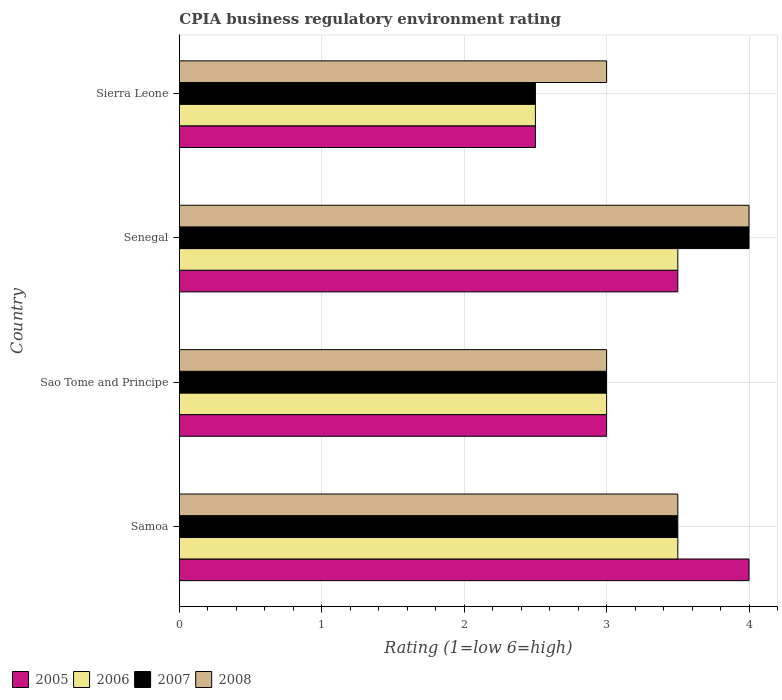How many bars are there on the 1st tick from the top?
Offer a terse response. 4. How many bars are there on the 1st tick from the bottom?
Offer a terse response. 4. What is the label of the 1st group of bars from the top?
Provide a short and direct response. Sierra Leone. What is the CPIA rating in 2007 in Senegal?
Give a very brief answer. 4. Across all countries, what is the minimum CPIA rating in 2007?
Provide a short and direct response. 2.5. In which country was the CPIA rating in 2008 maximum?
Provide a short and direct response. Senegal. In which country was the CPIA rating in 2006 minimum?
Your response must be concise. Sierra Leone. What is the total CPIA rating in 2005 in the graph?
Make the answer very short. 13. What is the difference between the CPIA rating in 2005 in Sao Tome and Principe and that in Sierra Leone?
Your answer should be compact. 0.5. What is the average CPIA rating in 2005 per country?
Make the answer very short. 3.25. What is the difference between the CPIA rating in 2007 and CPIA rating in 2006 in Samoa?
Offer a very short reply. 0. What is the ratio of the CPIA rating in 2005 in Senegal to that in Sierra Leone?
Your answer should be very brief. 1.4. What is the difference between the highest and the second highest CPIA rating in 2008?
Provide a succinct answer. 0.5. Is the sum of the CPIA rating in 2007 in Samoa and Senegal greater than the maximum CPIA rating in 2005 across all countries?
Your response must be concise. Yes. Is it the case that in every country, the sum of the CPIA rating in 2008 and CPIA rating in 2005 is greater than the sum of CPIA rating in 2006 and CPIA rating in 2007?
Your response must be concise. No. How many bars are there?
Give a very brief answer. 16. What is the difference between two consecutive major ticks on the X-axis?
Give a very brief answer. 1. Are the values on the major ticks of X-axis written in scientific E-notation?
Make the answer very short. No. What is the title of the graph?
Make the answer very short. CPIA business regulatory environment rating. What is the label or title of the Y-axis?
Your response must be concise. Country. What is the Rating (1=low 6=high) of 2005 in Sao Tome and Principe?
Offer a very short reply. 3. What is the Rating (1=low 6=high) of 2007 in Senegal?
Offer a terse response. 4. What is the Rating (1=low 6=high) in 2008 in Senegal?
Offer a terse response. 4. What is the Rating (1=low 6=high) in 2005 in Sierra Leone?
Provide a short and direct response. 2.5. What is the Rating (1=low 6=high) of 2006 in Sierra Leone?
Make the answer very short. 2.5. Across all countries, what is the maximum Rating (1=low 6=high) in 2006?
Keep it short and to the point. 3.5. Across all countries, what is the maximum Rating (1=low 6=high) in 2007?
Your response must be concise. 4. Across all countries, what is the maximum Rating (1=low 6=high) in 2008?
Provide a succinct answer. 4. Across all countries, what is the minimum Rating (1=low 6=high) in 2006?
Keep it short and to the point. 2.5. Across all countries, what is the minimum Rating (1=low 6=high) of 2007?
Ensure brevity in your answer.  2.5. What is the total Rating (1=low 6=high) in 2005 in the graph?
Give a very brief answer. 13. What is the total Rating (1=low 6=high) in 2006 in the graph?
Provide a short and direct response. 12.5. What is the difference between the Rating (1=low 6=high) of 2005 in Samoa and that in Sao Tome and Principe?
Make the answer very short. 1. What is the difference between the Rating (1=low 6=high) of 2006 in Samoa and that in Sao Tome and Principe?
Offer a terse response. 0.5. What is the difference between the Rating (1=low 6=high) of 2008 in Samoa and that in Senegal?
Your answer should be compact. -0.5. What is the difference between the Rating (1=low 6=high) of 2005 in Samoa and that in Sierra Leone?
Your answer should be very brief. 1.5. What is the difference between the Rating (1=low 6=high) in 2006 in Samoa and that in Sierra Leone?
Make the answer very short. 1. What is the difference between the Rating (1=low 6=high) of 2005 in Sao Tome and Principe and that in Sierra Leone?
Offer a terse response. 0.5. What is the difference between the Rating (1=low 6=high) of 2007 in Sao Tome and Principe and that in Sierra Leone?
Give a very brief answer. 0.5. What is the difference between the Rating (1=low 6=high) in 2006 in Senegal and that in Sierra Leone?
Keep it short and to the point. 1. What is the difference between the Rating (1=low 6=high) of 2007 in Senegal and that in Sierra Leone?
Keep it short and to the point. 1.5. What is the difference between the Rating (1=low 6=high) of 2008 in Senegal and that in Sierra Leone?
Your answer should be compact. 1. What is the difference between the Rating (1=low 6=high) of 2005 in Samoa and the Rating (1=low 6=high) of 2006 in Sao Tome and Principe?
Your answer should be compact. 1. What is the difference between the Rating (1=low 6=high) of 2006 in Samoa and the Rating (1=low 6=high) of 2007 in Sao Tome and Principe?
Keep it short and to the point. 0.5. What is the difference between the Rating (1=low 6=high) in 2006 in Samoa and the Rating (1=low 6=high) in 2008 in Sao Tome and Principe?
Provide a succinct answer. 0.5. What is the difference between the Rating (1=low 6=high) in 2005 in Samoa and the Rating (1=low 6=high) in 2007 in Senegal?
Your answer should be compact. 0. What is the difference between the Rating (1=low 6=high) in 2007 in Samoa and the Rating (1=low 6=high) in 2008 in Senegal?
Provide a short and direct response. -0.5. What is the difference between the Rating (1=low 6=high) in 2005 in Samoa and the Rating (1=low 6=high) in 2006 in Sierra Leone?
Your answer should be compact. 1.5. What is the difference between the Rating (1=low 6=high) in 2005 in Samoa and the Rating (1=low 6=high) in 2008 in Sierra Leone?
Your answer should be very brief. 1. What is the difference between the Rating (1=low 6=high) of 2006 in Samoa and the Rating (1=low 6=high) of 2008 in Sierra Leone?
Offer a terse response. 0.5. What is the difference between the Rating (1=low 6=high) of 2005 in Sao Tome and Principe and the Rating (1=low 6=high) of 2006 in Senegal?
Keep it short and to the point. -0.5. What is the difference between the Rating (1=low 6=high) of 2005 in Sao Tome and Principe and the Rating (1=low 6=high) of 2007 in Senegal?
Your response must be concise. -1. What is the difference between the Rating (1=low 6=high) in 2005 in Sao Tome and Principe and the Rating (1=low 6=high) in 2008 in Senegal?
Provide a short and direct response. -1. What is the difference between the Rating (1=low 6=high) in 2006 in Sao Tome and Principe and the Rating (1=low 6=high) in 2007 in Senegal?
Keep it short and to the point. -1. What is the difference between the Rating (1=low 6=high) in 2007 in Sao Tome and Principe and the Rating (1=low 6=high) in 2008 in Senegal?
Offer a very short reply. -1. What is the difference between the Rating (1=low 6=high) of 2005 in Sao Tome and Principe and the Rating (1=low 6=high) of 2008 in Sierra Leone?
Make the answer very short. 0. What is the difference between the Rating (1=low 6=high) of 2006 in Sao Tome and Principe and the Rating (1=low 6=high) of 2007 in Sierra Leone?
Give a very brief answer. 0.5. What is the difference between the Rating (1=low 6=high) in 2006 in Sao Tome and Principe and the Rating (1=low 6=high) in 2008 in Sierra Leone?
Offer a terse response. 0. What is the difference between the Rating (1=low 6=high) in 2005 in Senegal and the Rating (1=low 6=high) in 2006 in Sierra Leone?
Keep it short and to the point. 1. What is the difference between the Rating (1=low 6=high) of 2005 in Senegal and the Rating (1=low 6=high) of 2008 in Sierra Leone?
Give a very brief answer. 0.5. What is the average Rating (1=low 6=high) in 2005 per country?
Offer a very short reply. 3.25. What is the average Rating (1=low 6=high) in 2006 per country?
Make the answer very short. 3.12. What is the average Rating (1=low 6=high) in 2007 per country?
Offer a terse response. 3.25. What is the average Rating (1=low 6=high) in 2008 per country?
Provide a succinct answer. 3.38. What is the difference between the Rating (1=low 6=high) of 2005 and Rating (1=low 6=high) of 2008 in Samoa?
Ensure brevity in your answer.  0.5. What is the difference between the Rating (1=low 6=high) of 2006 and Rating (1=low 6=high) of 2007 in Samoa?
Your answer should be very brief. 0. What is the difference between the Rating (1=low 6=high) of 2006 and Rating (1=low 6=high) of 2008 in Samoa?
Keep it short and to the point. 0. What is the difference between the Rating (1=low 6=high) of 2005 and Rating (1=low 6=high) of 2008 in Sao Tome and Principe?
Give a very brief answer. 0. What is the difference between the Rating (1=low 6=high) in 2006 and Rating (1=low 6=high) in 2008 in Sao Tome and Principe?
Ensure brevity in your answer.  0. What is the difference between the Rating (1=low 6=high) of 2007 and Rating (1=low 6=high) of 2008 in Sao Tome and Principe?
Your answer should be very brief. 0. What is the difference between the Rating (1=low 6=high) of 2005 and Rating (1=low 6=high) of 2008 in Senegal?
Offer a very short reply. -0.5. What is the difference between the Rating (1=low 6=high) in 2007 and Rating (1=low 6=high) in 2008 in Senegal?
Your response must be concise. 0. What is the difference between the Rating (1=low 6=high) in 2005 and Rating (1=low 6=high) in 2006 in Sierra Leone?
Your answer should be very brief. 0. What is the difference between the Rating (1=low 6=high) in 2005 and Rating (1=low 6=high) in 2008 in Sierra Leone?
Give a very brief answer. -0.5. What is the difference between the Rating (1=low 6=high) in 2006 and Rating (1=low 6=high) in 2007 in Sierra Leone?
Make the answer very short. 0. What is the difference between the Rating (1=low 6=high) of 2006 and Rating (1=low 6=high) of 2008 in Sierra Leone?
Ensure brevity in your answer.  -0.5. What is the difference between the Rating (1=low 6=high) of 2007 and Rating (1=low 6=high) of 2008 in Sierra Leone?
Keep it short and to the point. -0.5. What is the ratio of the Rating (1=low 6=high) in 2007 in Samoa to that in Sao Tome and Principe?
Provide a succinct answer. 1.17. What is the ratio of the Rating (1=low 6=high) in 2008 in Samoa to that in Sao Tome and Principe?
Provide a succinct answer. 1.17. What is the ratio of the Rating (1=low 6=high) of 2006 in Samoa to that in Senegal?
Offer a terse response. 1. What is the ratio of the Rating (1=low 6=high) of 2007 in Samoa to that in Senegal?
Keep it short and to the point. 0.88. What is the ratio of the Rating (1=low 6=high) in 2007 in Samoa to that in Sierra Leone?
Your answer should be compact. 1.4. What is the ratio of the Rating (1=low 6=high) in 2008 in Samoa to that in Sierra Leone?
Your answer should be compact. 1.17. What is the ratio of the Rating (1=low 6=high) in 2006 in Sao Tome and Principe to that in Senegal?
Offer a terse response. 0.86. What is the ratio of the Rating (1=low 6=high) of 2008 in Sao Tome and Principe to that in Senegal?
Keep it short and to the point. 0.75. What is the ratio of the Rating (1=low 6=high) of 2006 in Sao Tome and Principe to that in Sierra Leone?
Offer a terse response. 1.2. What is the ratio of the Rating (1=low 6=high) in 2006 in Senegal to that in Sierra Leone?
Give a very brief answer. 1.4. What is the ratio of the Rating (1=low 6=high) in 2007 in Senegal to that in Sierra Leone?
Provide a short and direct response. 1.6. What is the difference between the highest and the second highest Rating (1=low 6=high) of 2005?
Give a very brief answer. 0.5. What is the difference between the highest and the second highest Rating (1=low 6=high) of 2006?
Provide a succinct answer. 0. What is the difference between the highest and the second highest Rating (1=low 6=high) in 2007?
Make the answer very short. 0.5. What is the difference between the highest and the lowest Rating (1=low 6=high) of 2008?
Provide a short and direct response. 1. 